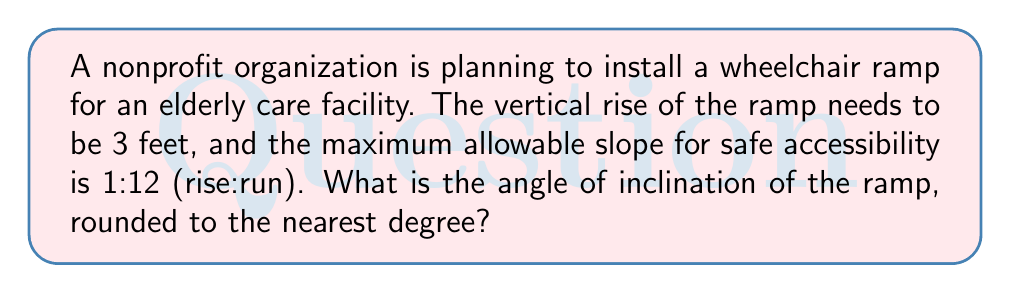Teach me how to tackle this problem. Let's approach this step-by-step:

1) First, we need to understand what a 1:12 slope means. It indicates that for every 1 unit of rise, there are 12 units of run.

2) Given that the vertical rise is 3 feet, we can calculate the horizontal run:
   $$ \text{Run} = 3 \text{ feet} \times 12 = 36 \text{ feet} $$

3) Now we have a right triangle with:
   - Opposite side (rise) = 3 feet
   - Adjacent side (run) = 36 feet

4) To find the angle of inclination, we can use the arctangent function:
   $$ \theta = \arctan(\frac{\text{opposite}}{\text{adjacent}}) $$

5) Substituting our values:
   $$ \theta = \arctan(\frac{3}{36}) = \arctan(0.0833) $$

6) Using a calculator or trigonometric tables:
   $$ \theta \approx 4.76^\circ $$

7) Rounding to the nearest degree:
   $$ \theta \approx 5^\circ $$
Answer: $5^\circ$ 